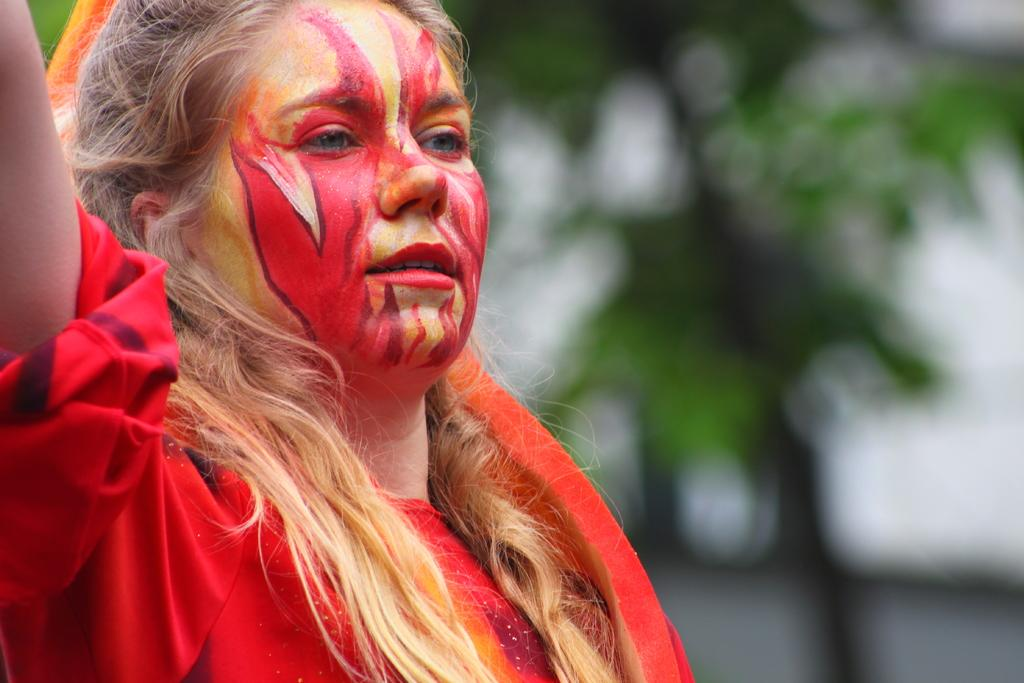Who is the main subject in the image? There is a girl in the image. What is the girl wearing? The girl is wearing a red dress. Can you describe any additional details about the girl's appearance? There is paint on the girl's face. What can be seen in the background of the image? The background of the image is green, and it is blurred. How many mint leaves are visible in the image? There are no mint leaves present in the image. What type of beam is supporting the girl in the image? The girl is not being supported by a beam in the image; she is standing on her own. 